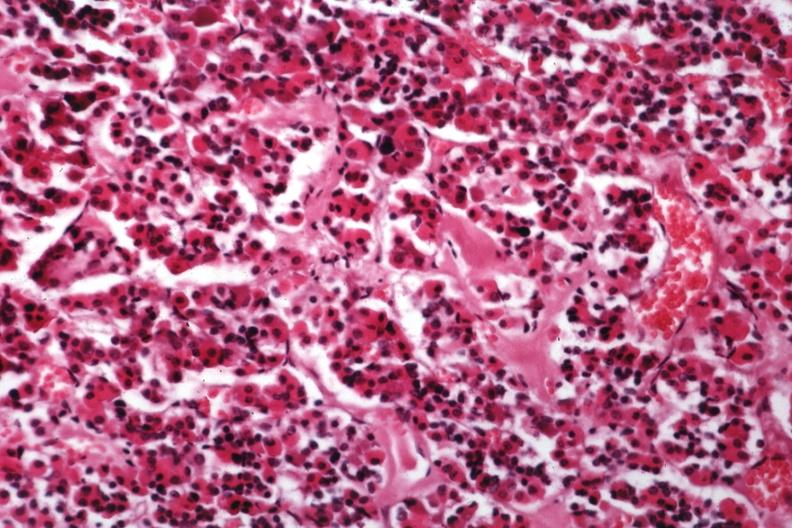s endocrine present?
Answer the question using a single word or phrase. Yes 